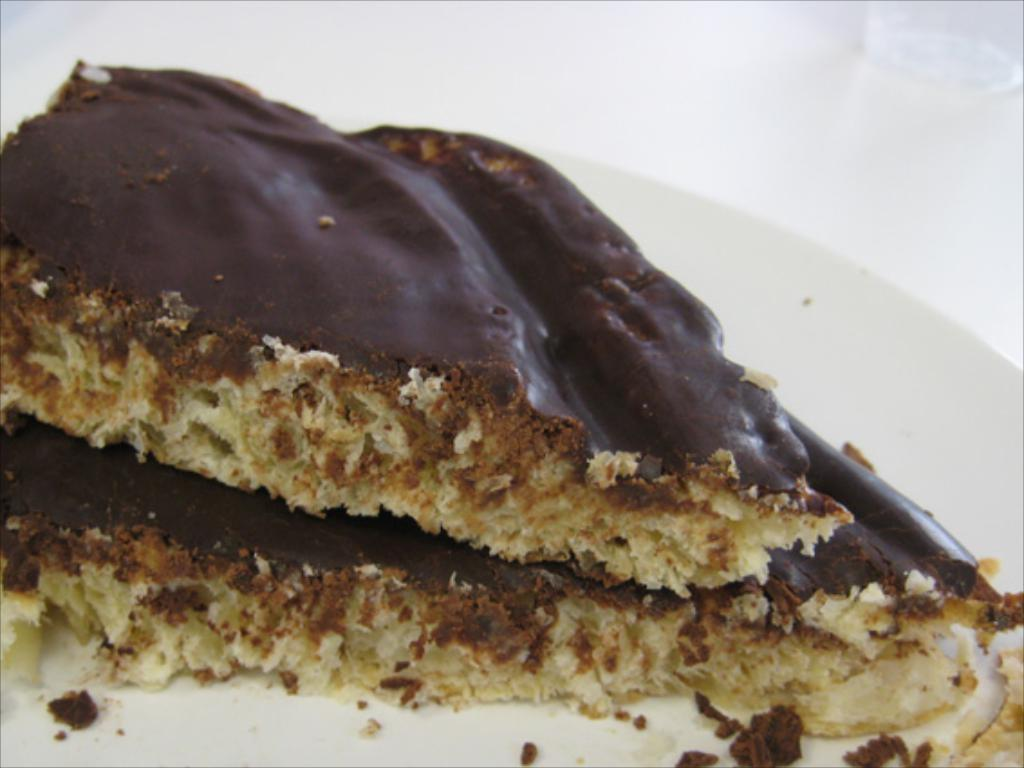What is present on the plate in the image? There is food on the plate in the image. What color is the plate? The plate is white. What colors can be seen in the food? The food has cream and brown colors. How many cows are visible in the image? There are no cows present in the image. What type of table is the plate placed on in the image? The provided facts do not mention a table, so we cannot determine if there is one or what type it might be. 